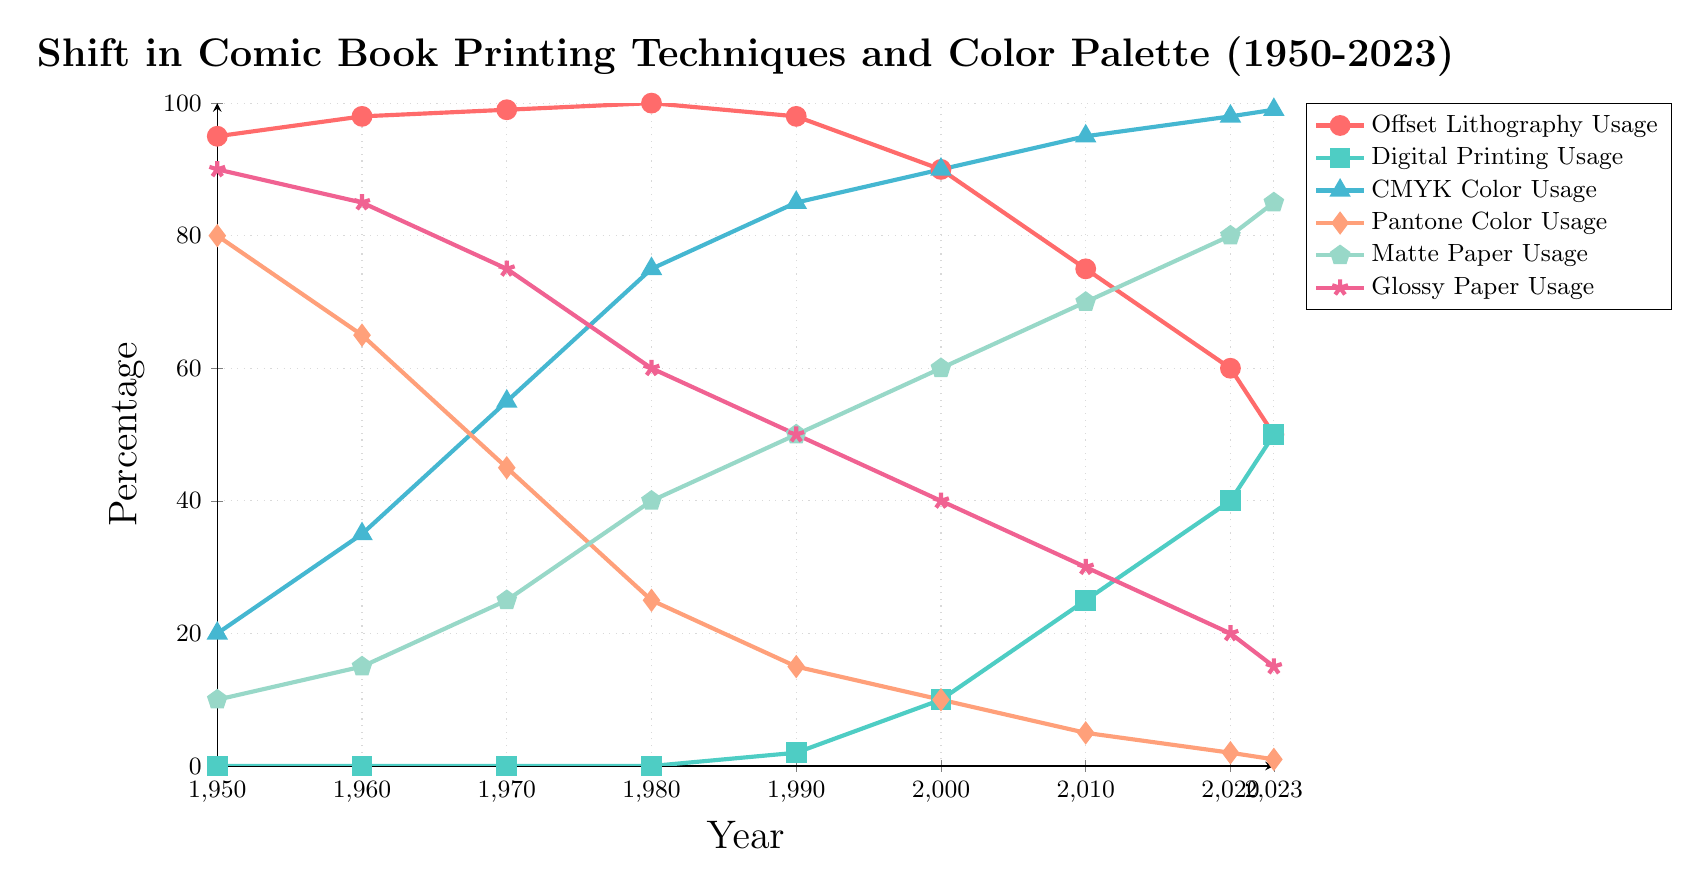What printing technique shows the largest decrease in usage from 1950 to 2023? Offset Lithography Usage decreases from 95% in 1950 to 50% in 2023. The difference is 95 - 50 = 45%.
Answer: Offset Lithography Usage Comparing 1980 and 2023, which year had a higher usage of glossy paper? In 1980, Glossy Paper Usage is at 60%, while in 2023 it is at 15%. 60% is greater than 15%.
Answer: 1980 During which decade did the usage of CMYK Color first surpass Pantone Color? In the 1970s, CMYK Color Usage is 55% and Pantone Color Usage is 45%. Before the 1970s the Pantone usage was higher.
Answer: 1970s What is the average usage of Digital Printing from 1950 to 2023? Only non-zero values from 1990 onwards are considered. Sum them up: (2 + 10 + 25 + 40 + 50) = 127%. There are 5 data points, so the average = 127/5 = 25.4%
Answer: 25.4% Which color in the figure represents CMYK Color Usage? The figure shows CMYK Color Usage in blue with triangular markers.
Answer: Blue with triangular markers How does the usage of Matte Paper compare to Glossy Paper in 2023? Matte Paper Usage is 85% while Glossy Paper Usage is 15%. Matte is greater than Glossy.
Answer: Matte Paper Usage is higher Calculate the average Offset Lithography Usage from 1950 to 2023. Sum up all values: (95 + 98 + 99 + 100 + 98 + 90 + 75 + 60 + 50) = 765%. There are 9 data points, so the average = 765/9 = 85%.
Answer: 85% What is the difference in CMYK usage between 2020 and 2023? In 2020, CMYK Usage is 98%. In 2023, it is 99%. The difference is 99 - 98 = 1%.
Answer: 1% Which year shows an equal usage of Offset Lithography and Digital Printing? In 2023, both Offset Lithography and Digital Printing Usage are at 50%.
Answer: 2023 By how many percentage points did Digital Printing Usage increase between 2000 and 2020? In 2000, Digital Printing Usage is 10%. In 2020, it is 40%. The increase is 40 - 10 = 30%.
Answer: 30% 